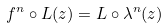<formula> <loc_0><loc_0><loc_500><loc_500>f ^ { n } \circ L ( z ) = L \circ \lambda ^ { n } ( z )</formula> 